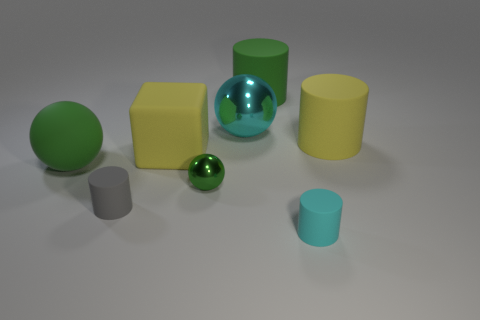Are there any large things that have the same color as the large rubber block?
Ensure brevity in your answer.  Yes. Does the big green cylinder have the same material as the tiny gray cylinder?
Ensure brevity in your answer.  Yes. There is a large green rubber ball; what number of shiny things are in front of it?
Your answer should be very brief. 1. The object that is both on the left side of the large yellow cube and behind the gray matte cylinder is made of what material?
Your answer should be compact. Rubber. What number of blue metallic things have the same size as the matte ball?
Offer a very short reply. 0. What is the color of the big sphere behind the yellow matte object behind the yellow matte cube?
Your response must be concise. Cyan. Are there any tiny gray things?
Your answer should be compact. Yes. Does the small gray thing have the same shape as the cyan metal object?
Ensure brevity in your answer.  No. There is a matte ball that is the same color as the tiny shiny object; what size is it?
Ensure brevity in your answer.  Large. What number of big green rubber spheres are behind the big green thing behind the large cyan sphere?
Your response must be concise. 0. 